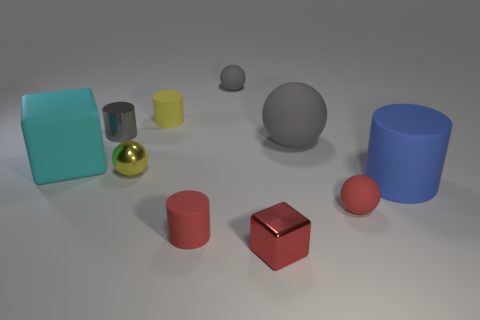Subtract 1 cylinders. How many cylinders are left? 3 Subtract all cylinders. How many objects are left? 6 Add 7 red things. How many red things are left? 10 Add 1 small metal cylinders. How many small metal cylinders exist? 2 Subtract 0 brown spheres. How many objects are left? 10 Subtract all small yellow balls. Subtract all big cyan matte objects. How many objects are left? 8 